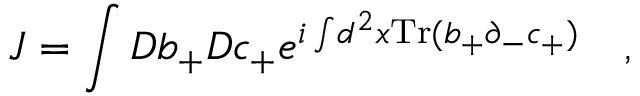Convert formula to latex. <formula><loc_0><loc_0><loc_500><loc_500>J = \int D b _ { + } D c _ { + } e ^ { i \int \, d ^ { 2 } x T r ( b _ { + } \partial _ { - } c _ { + } ) } \quad ,</formula> 